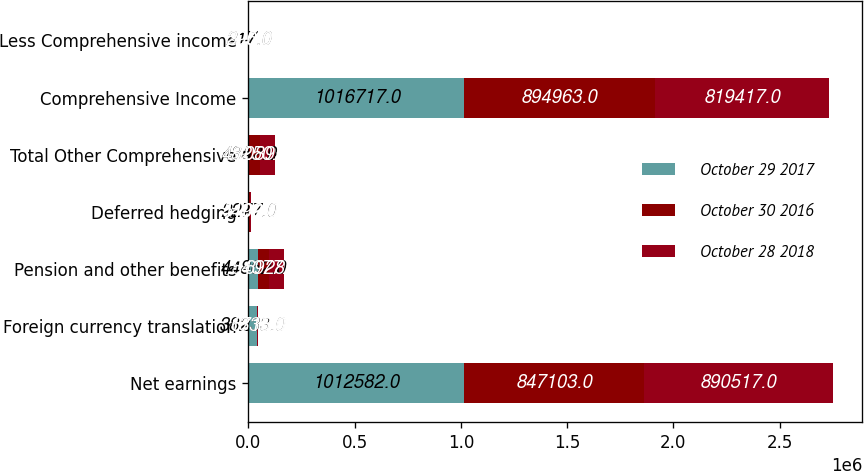Convert chart to OTSL. <chart><loc_0><loc_0><loc_500><loc_500><stacked_bar_chart><ecel><fcel>Net earnings<fcel>Foreign currency translation<fcel>Pension and other benefits<fcel>Deferred hedging<fcel>Total Other Comprehensive<fcel>Comprehensive Income<fcel>Less Comprehensive income<nl><fcel>October 29 2017<fcel>1.01258e+06<fcel>38233<fcel>44862<fcel>2277<fcel>4352<fcel>1.01672e+06<fcel>217<nl><fcel>October 30 2016<fcel>847103<fcel>1335<fcel>54077<fcel>4492<fcel>48250<fcel>894963<fcel>390<nl><fcel>October 28 2018<fcel>890517<fcel>6718<fcel>69286<fcel>5109<fcel>70895<fcel>819417<fcel>205<nl></chart> 